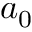<formula> <loc_0><loc_0><loc_500><loc_500>a _ { 0 }</formula> 